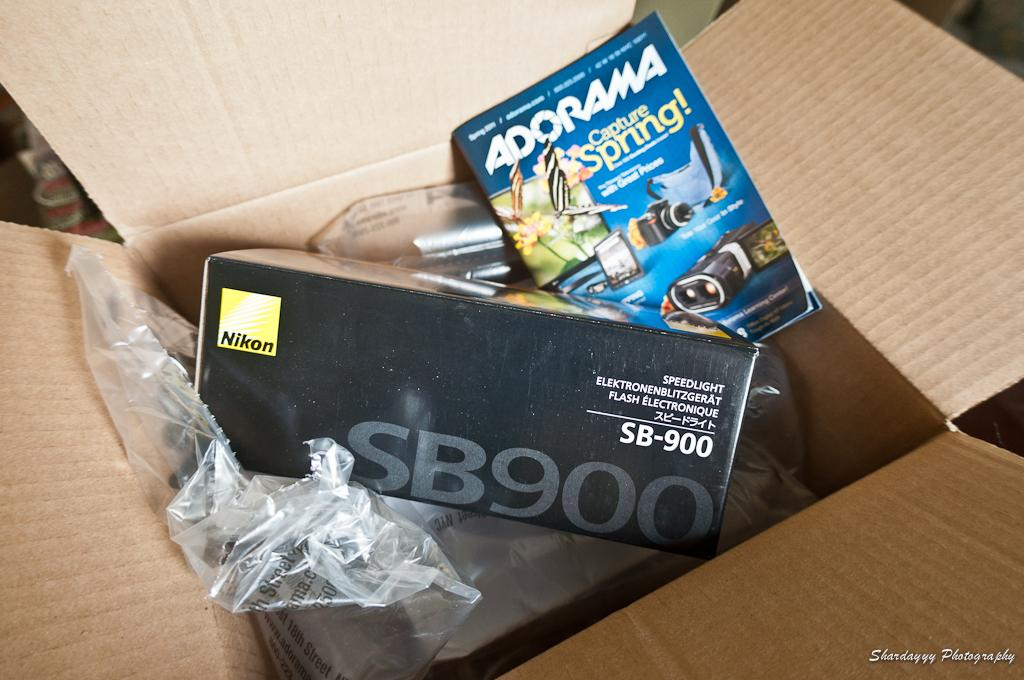<image>
Share a concise interpretation of the image provided. A Nikon brand product is sitting inside of a cardboard box. 